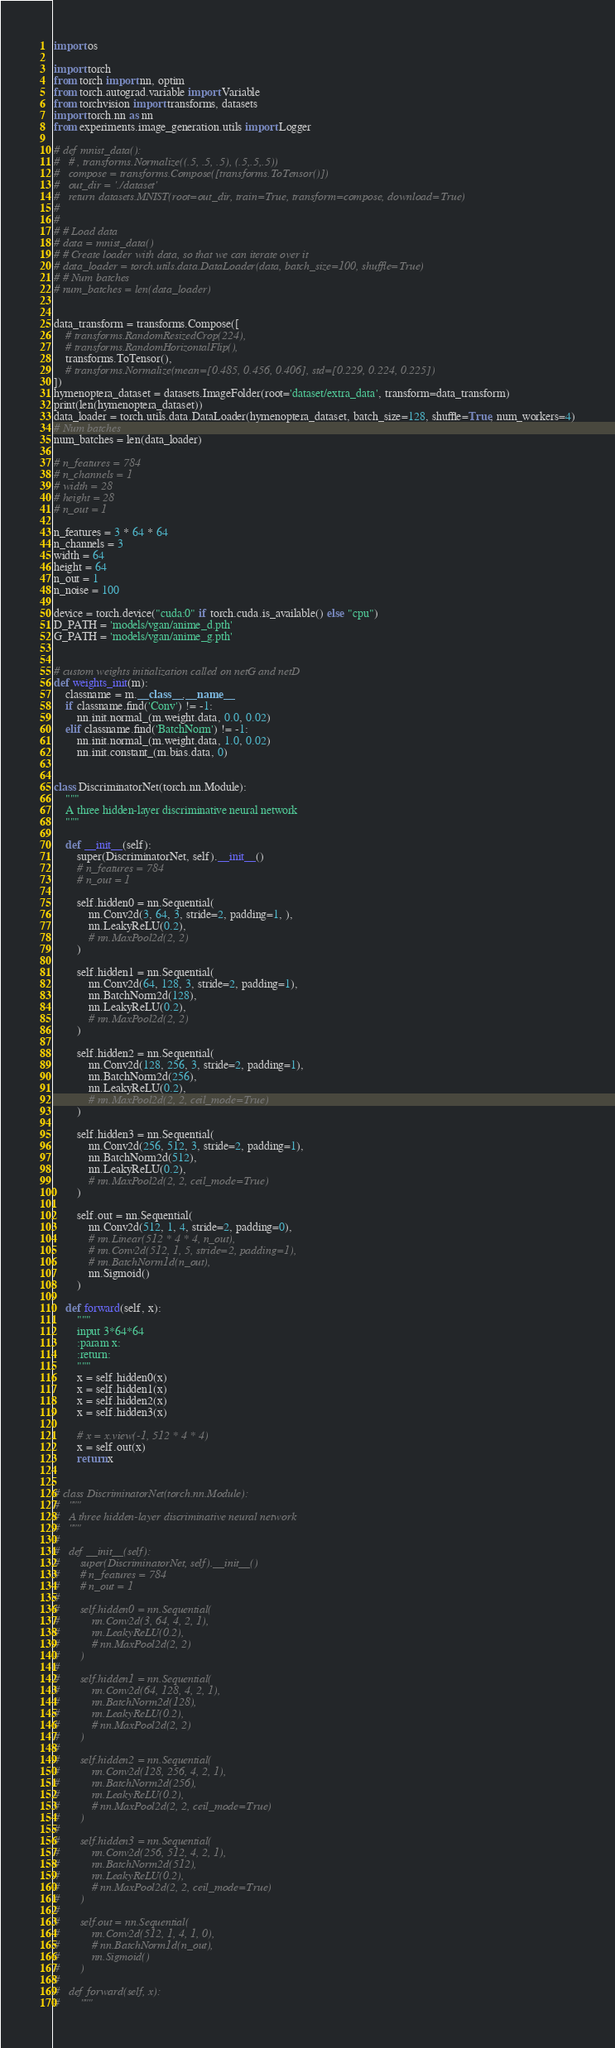<code> <loc_0><loc_0><loc_500><loc_500><_Python_>import os

import torch
from torch import nn, optim
from torch.autograd.variable import Variable
from torchvision import transforms, datasets
import torch.nn as nn
from experiments.image_generation.utils import Logger

# def mnist_data():
# 	# , transforms.Normalize((.5, .5, .5), (.5,.5,.5))
# 	compose = transforms.Compose([transforms.ToTensor()])
# 	out_dir = './dataset'
# 	return datasets.MNIST(root=out_dir, train=True, transform=compose, download=True)
#
#
# # Load data
# data = mnist_data()
# # Create loader with data, so that we can iterate over it
# data_loader = torch.utils.data.DataLoader(data, batch_size=100, shuffle=True)
# # Num batches
# num_batches = len(data_loader)


data_transform = transforms.Compose([
	# transforms.RandomResizedCrop(224),
	# transforms.RandomHorizontalFlip(),
	transforms.ToTensor(),
	# transforms.Normalize(mean=[0.485, 0.456, 0.406], std=[0.229, 0.224, 0.225])
])
hymenoptera_dataset = datasets.ImageFolder(root='dataset/extra_data', transform=data_transform)
print(len(hymenoptera_dataset))
data_loader = torch.utils.data.DataLoader(hymenoptera_dataset, batch_size=128, shuffle=True, num_workers=4)
# Num batches
num_batches = len(data_loader)

# n_features = 784
# n_channels = 1
# width = 28
# height = 28
# n_out = 1

n_features = 3 * 64 * 64
n_channels = 3
width = 64
height = 64
n_out = 1
n_noise = 100

device = torch.device("cuda:0" if torch.cuda.is_available() else "cpu")
D_PATH = 'models/vgan/anime_d.pth'
G_PATH = 'models/vgan/anime_g.pth'


# custom weights initialization called on netG and netD
def weights_init(m):
	classname = m.__class__.__name__
	if classname.find('Conv') != -1:
		nn.init.normal_(m.weight.data, 0.0, 0.02)
	elif classname.find('BatchNorm') != -1:
		nn.init.normal_(m.weight.data, 1.0, 0.02)
		nn.init.constant_(m.bias.data, 0)


class DiscriminatorNet(torch.nn.Module):
	"""
	A three hidden-layer discriminative neural network
	"""

	def __init__(self):
		super(DiscriminatorNet, self).__init__()
		# n_features = 784
		# n_out = 1

		self.hidden0 = nn.Sequential(
			nn.Conv2d(3, 64, 3, stride=2, padding=1, ),
			nn.LeakyReLU(0.2),
			# nn.MaxPool2d(2, 2)
		)

		self.hidden1 = nn.Sequential(
			nn.Conv2d(64, 128, 3, stride=2, padding=1),
			nn.BatchNorm2d(128),
			nn.LeakyReLU(0.2),
			# nn.MaxPool2d(2, 2)
		)

		self.hidden2 = nn.Sequential(
			nn.Conv2d(128, 256, 3, stride=2, padding=1),
			nn.BatchNorm2d(256),
			nn.LeakyReLU(0.2),
			# nn.MaxPool2d(2, 2, ceil_mode=True)
		)

		self.hidden3 = nn.Sequential(
			nn.Conv2d(256, 512, 3, stride=2, padding=1),
			nn.BatchNorm2d(512),
			nn.LeakyReLU(0.2),
			# nn.MaxPool2d(2, 2, ceil_mode=True)
		)

		self.out = nn.Sequential(
			nn.Conv2d(512, 1, 4, stride=2, padding=0),
			# nn.Linear(512 * 4 * 4, n_out),
			# nn.Conv2d(512, 1, 5, stride=2, padding=1),
			# nn.BatchNorm1d(n_out),
			nn.Sigmoid()
		)

	def forward(self, x):
		"""
		input 3*64*64
		:param x:
		:return:
		"""
		x = self.hidden0(x)
		x = self.hidden1(x)
		x = self.hidden2(x)
		x = self.hidden3(x)

		# x = x.view(-1, 512 * 4 * 4)
		x = self.out(x)
		return x


# class DiscriminatorNet(torch.nn.Module):
# 	"""
# 	A three hidden-layer discriminative neural network
# 	"""
#
# 	def __init__(self):
# 		super(DiscriminatorNet, self).__init__()
# 		# n_features = 784
# 		# n_out = 1
#
# 		self.hidden0 = nn.Sequential(
# 			nn.Conv2d(3, 64, 4, 2, 1),
# 			nn.LeakyReLU(0.2),
# 			# nn.MaxPool2d(2, 2)
# 		)
#
# 		self.hidden1 = nn.Sequential(
# 			nn.Conv2d(64, 128, 4, 2, 1),
# 			nn.BatchNorm2d(128),
# 			nn.LeakyReLU(0.2),
# 			# nn.MaxPool2d(2, 2)
# 		)
#
# 		self.hidden2 = nn.Sequential(
# 			nn.Conv2d(128, 256, 4, 2, 1),
# 			nn.BatchNorm2d(256),
# 			nn.LeakyReLU(0.2),
# 			# nn.MaxPool2d(2, 2, ceil_mode=True)
# 		)
#
# 		self.hidden3 = nn.Sequential(
# 			nn.Conv2d(256, 512, 4, 2, 1),
# 			nn.BatchNorm2d(512),
# 			nn.LeakyReLU(0.2),
# 			# nn.MaxPool2d(2, 2, ceil_mode=True)
# 		)
#
# 		self.out = nn.Sequential(
# 			nn.Conv2d(512, 1, 4, 1, 0),
# 			# nn.BatchNorm1d(n_out),
# 			nn.Sigmoid()
# 		)
#
# 	def forward(self, x):
# 		"""</code> 